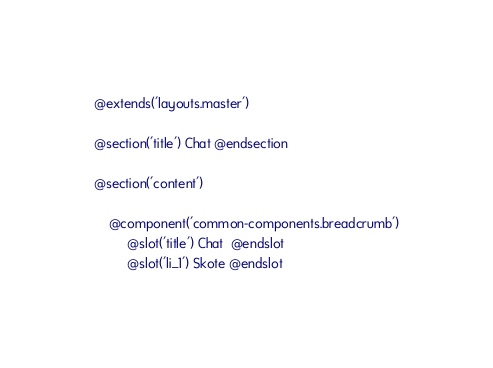<code> <loc_0><loc_0><loc_500><loc_500><_PHP_>@extends('layouts.master')

@section('title') Chat @endsection

@section('content')

    @component('common-components.breadcrumb')
         @slot('title') Chat  @endslot
         @slot('li_1') Skote @endslot</code> 